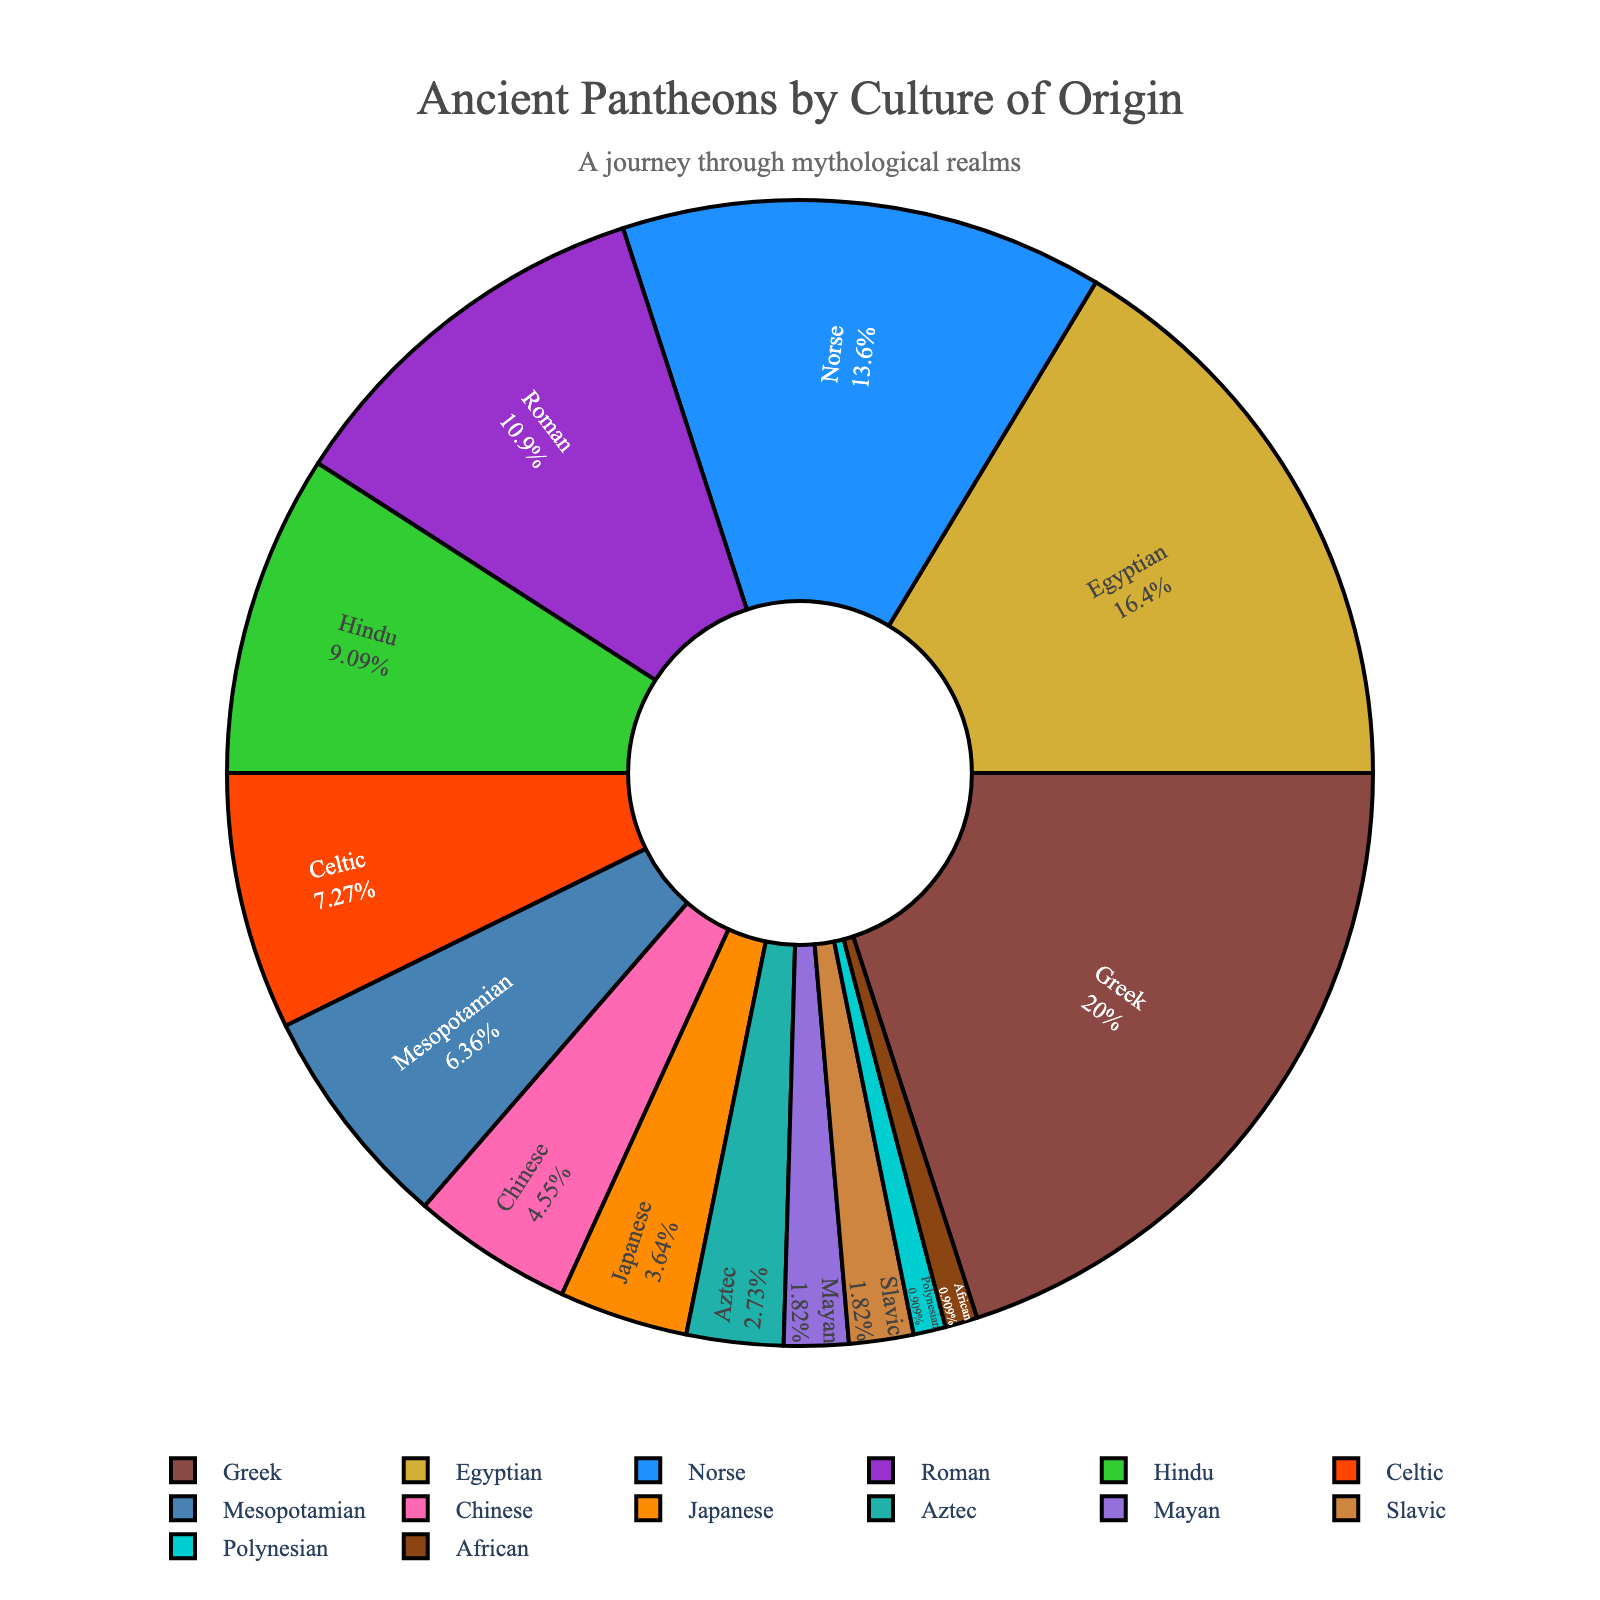What percentage of ancient pantheons are represented by Greek and Egyptian cultures combined? To find the combined percentage of Greek and Egyptian cultures, simply add their individual percentages: 22% (Greek) + 18% (Egyptian) = 40%.
Answer: 40% Which culture, between Norse and Roman, has a lower representation in the ancient pantheons? Comparing the percentages of Norse and Roman cultures, Norse has 15%, and Roman has 12%. Since 12% is less than 15%, Roman has the lower representation.
Answer: Roman How many cultures have a percentage less than or equal to 5%? Identify the cultures with percentages less than or equal to 5%: Chinese (5%), Japanese (4%), Aztec (3%), Mayan (2%), Slavic (2%), Polynesian (1%), and African (1%). There are a total of 7 cultures that meet this criterion.
Answer: 7 What is the difference in percentage between the highest and lowest represented cultures? The highest represented culture is Greek at 22%, and the lowest represented cultures are Polynesian and African, both at 1%. The difference is 22% - 1% = 21%.
Answer: 21% Which culture has a visually unique color other than earth tones or primary colors, and what is that color? Based on the described custom color palette, the culture with an eye-catching, non-traditional color is Celtic, associated with a distinctive pink/magenta hue.
Answer: Celtic 